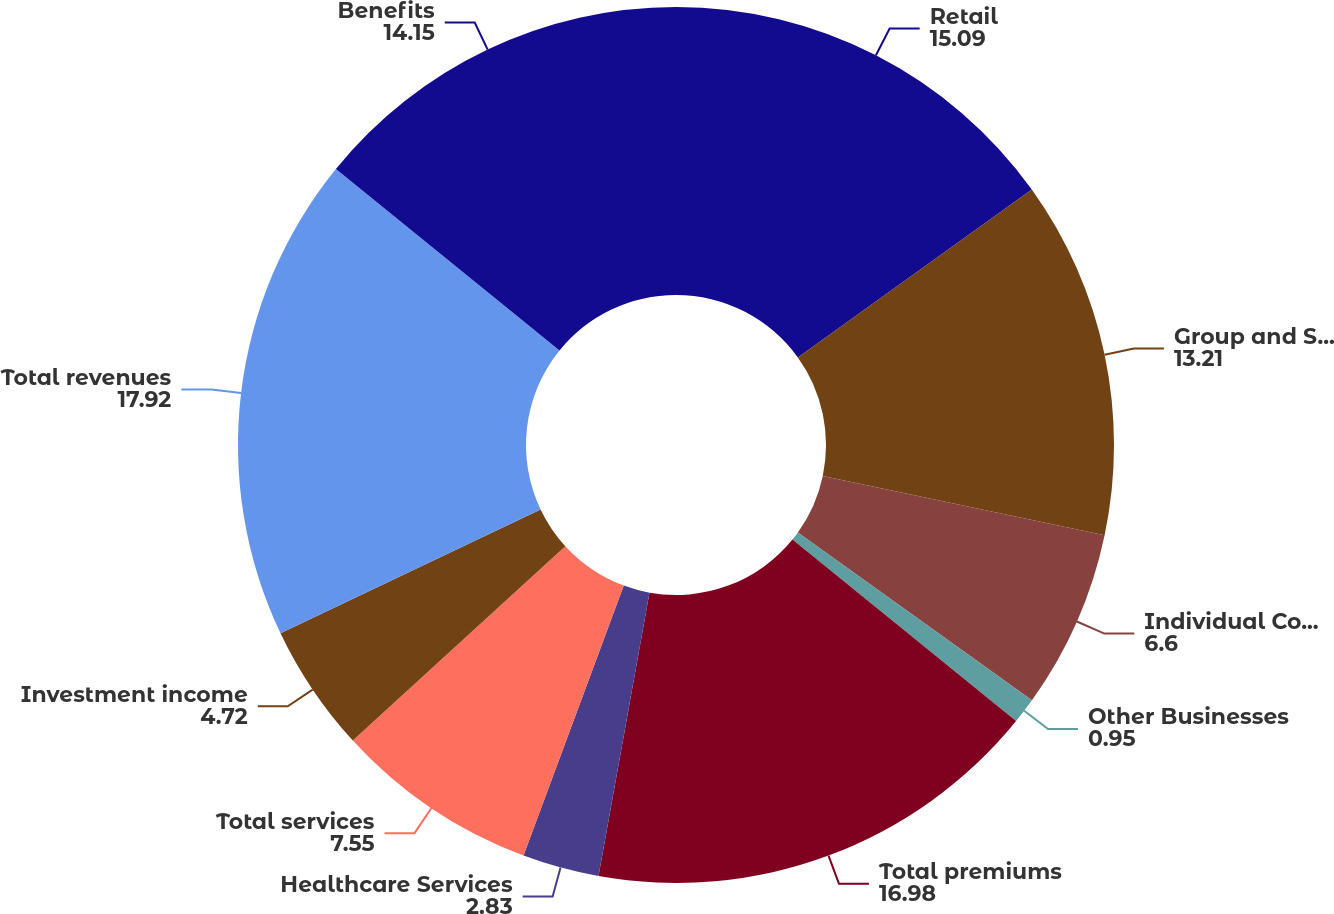<chart> <loc_0><loc_0><loc_500><loc_500><pie_chart><fcel>Retail<fcel>Group and Specialty<fcel>Individual Commercial<fcel>Other Businesses<fcel>Total premiums<fcel>Healthcare Services<fcel>Total services<fcel>Investment income<fcel>Total revenues<fcel>Benefits<nl><fcel>15.09%<fcel>13.21%<fcel>6.6%<fcel>0.95%<fcel>16.98%<fcel>2.83%<fcel>7.55%<fcel>4.72%<fcel>17.92%<fcel>14.15%<nl></chart> 